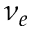Convert formula to latex. <formula><loc_0><loc_0><loc_500><loc_500>\nu _ { e }</formula> 